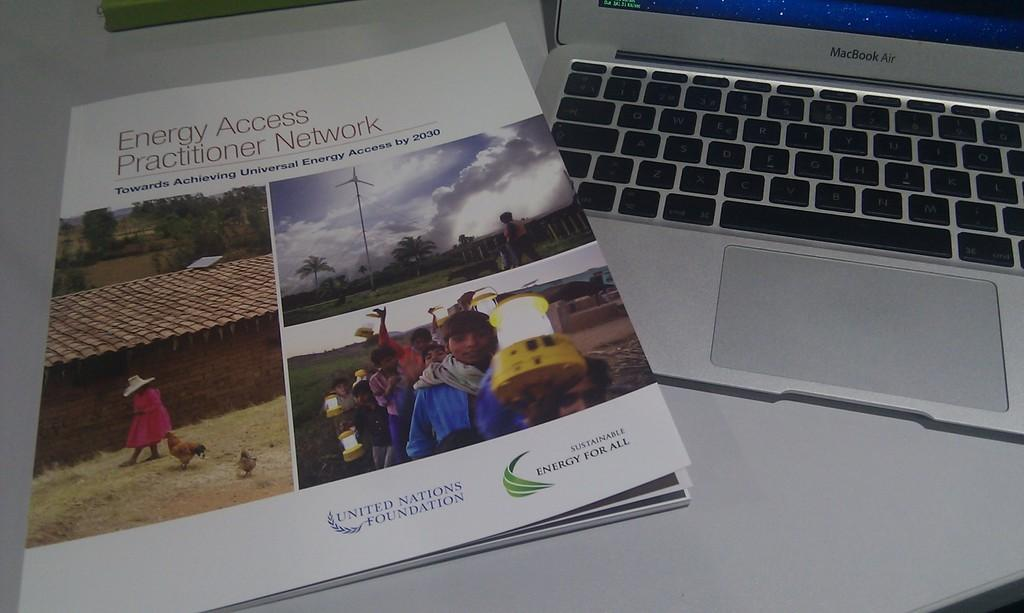<image>
Render a clear and concise summary of the photo. An Energy Access Practitioner Network booklet is next to a MacBook Air on a desk. 